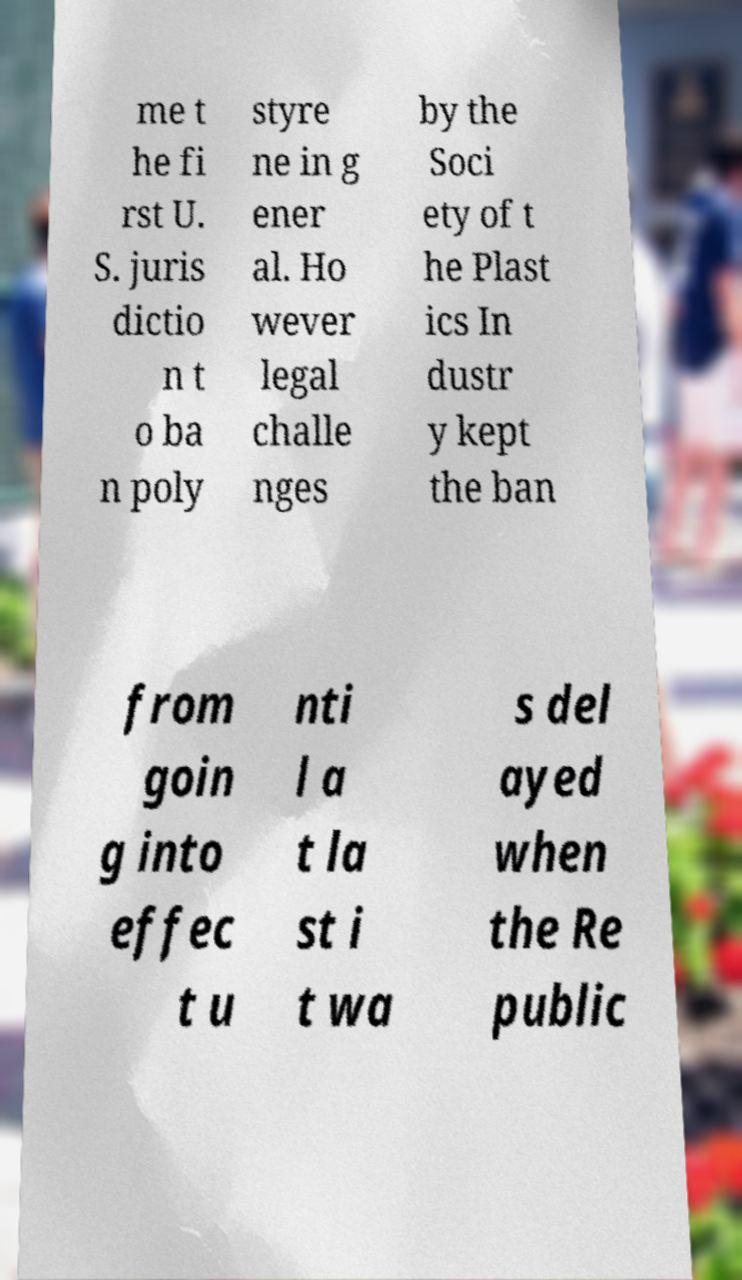There's text embedded in this image that I need extracted. Can you transcribe it verbatim? me t he fi rst U. S. juris dictio n t o ba n poly styre ne in g ener al. Ho wever legal challe nges by the Soci ety of t he Plast ics In dustr y kept the ban from goin g into effec t u nti l a t la st i t wa s del ayed when the Re public 